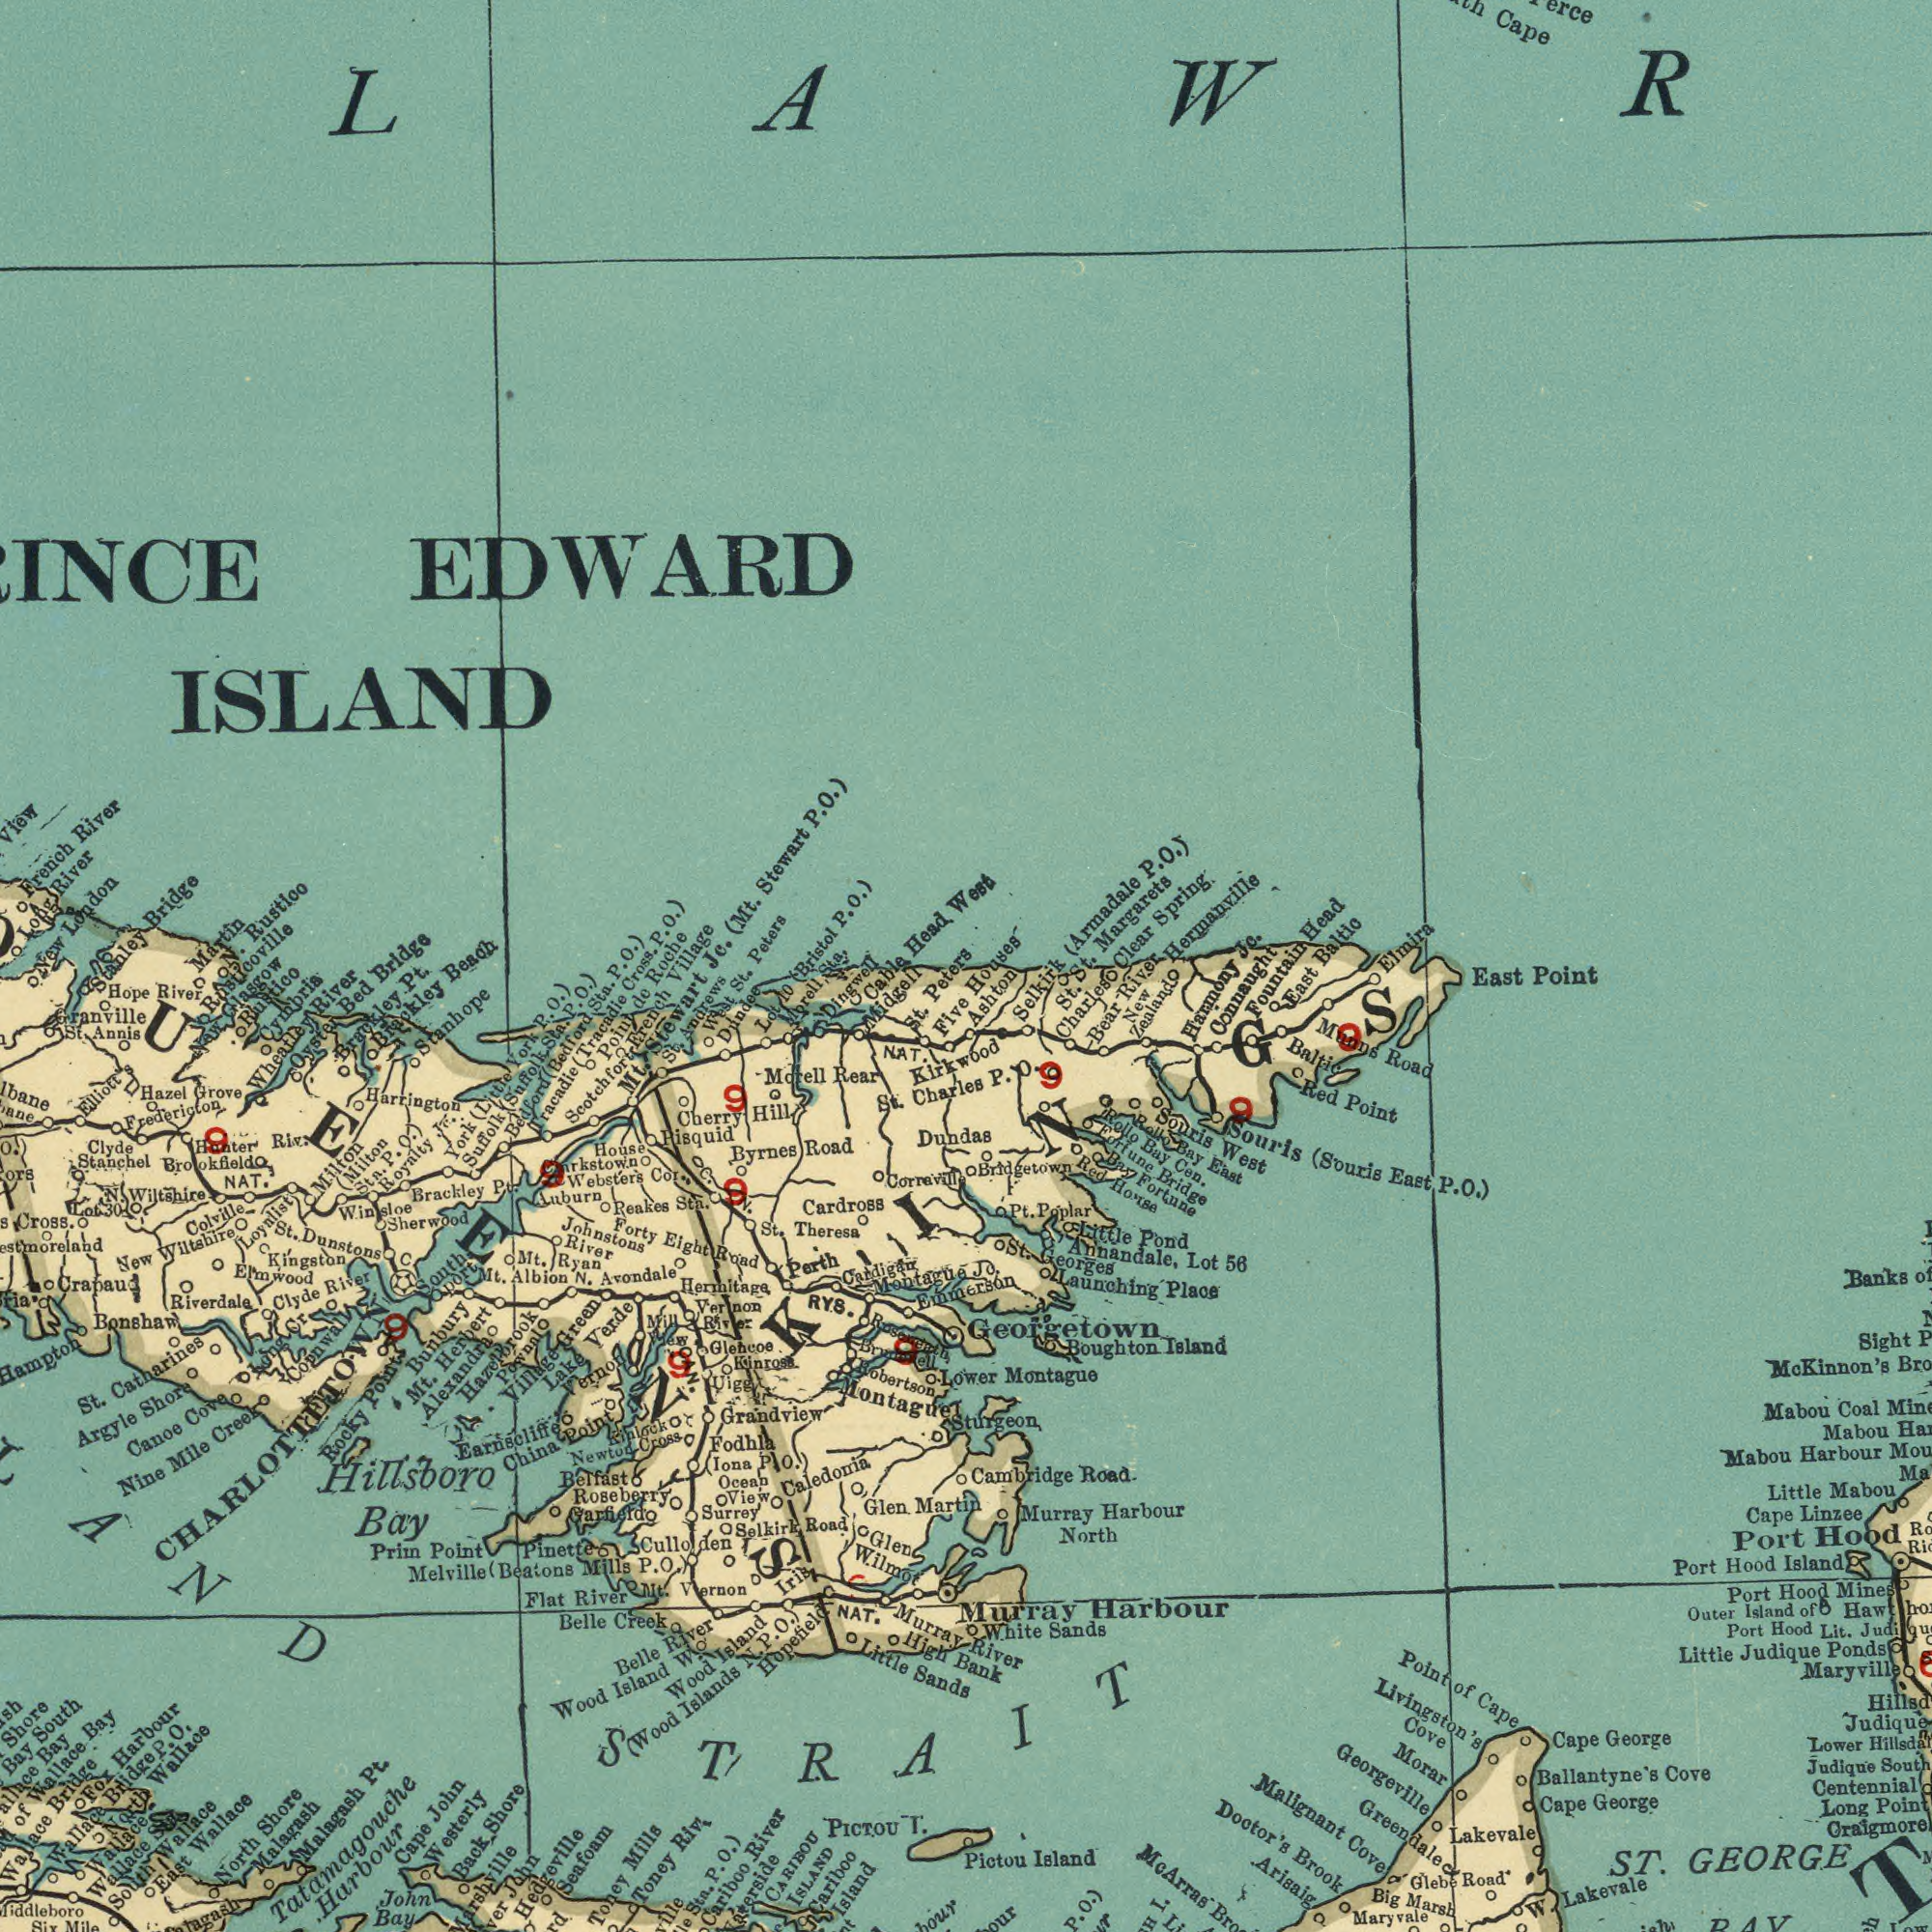What text is visible in the lower-right corner? Malignant Georgeville Harbour GEORGE Brook Livingston's Sands Lakevale Georgetown Cambridge Linzee Cape Judique Montague Lakevale Morar Mc Road Harbour (Souris Port Port Mabou Hood Greendale Cove Ponds Ballantyne's George Road Cape Red Point Point Little Island Port Mabou Boughton Cape Hood George Souris Island East Coal Little Banks Baltic Mabou Mabou Judique Marsh Lit. Port Arisaig Lower Murray Big East Long Sight Road Judique Murray Hood Mc Outer River Place Maryville Point East Maryvale Hood Pictou Cove P. Souris Harbour Point Island ST. KINGS Cape w. BAY Low Glebe of Cove Doctor's Arras Li I. P. 0.) of Kinnon's Bro Mines Island of South Centennial Bank White North Lower Sturgeon Launching St. Georges Annandale, Lot Little Pond Pt. Poplar Bridgetown Red House Bay Fortune Fortune Bridge Rollo Bay Cen. Rollo Bay West East O.) Munns Fountain Connaught Harmony New Zealand Bear River St. Charles St. Selkirk Ashton P. O. Jo. 9 9 9 56 What text can you see in the bottom-left section? Catharines Caledonia Little Argyle PICTOU Belle Wilmot Montague Grandview Bonshaw Creek Brackley I. Melville Murray Shore Seafoam Bay Riverdale Bunbury Canoe Mile Loyalist Sands North Crapaud Malagash Toney Nine Toney Wallace Martin Dunstons Hopefield Hampton Belle Rocky Flat Riv. Fodhla Surrey Colville Mills St. Winsloe NAT. Creek Shore El'mwood Selkirk (Beatons River Brookfield Riv. Clyde STRAIT CHARLOTTETOWN Cariboo Island CARIBOU ISLAND Cariboo River Stn. P. 0.) Hedgeville John Marshville Back Shore John Bay Cape John Westerly Tatamagouche Harbour Malagash Pt. East South Wallace Wallace Wallace Stn Wallace North Six Mile Wallace Bridge P. O. Fox Harbour Wallace Bridge of Wallace Bay Bay Bay South Shore Hillsboro High Glen Glen Corraville Five St. Peters Midgell Cable Dingwell Morell Lot Dundee West St. St. Andrews Mt. Stewart Scotchfort French Poiut de Tracadie (Tracadie Cross. Bedford (Bedford Sta. P. Suffolk (Suffolk Sta. P. O.) York (Little York P. O.) Harrington Stanhope Brackley Brackley Pt. Oyster Bed Wheatley River Cymbria Rustico New Glasgow Hope River Granville Sta. Annis Hazel Grove Elliott's Fredericton Clyde Stanchel O.) Cross. New Wiltshire N. Wiltshire Lot30 Hunter Sta. Kingston River Cove Long Cr. Cornwall Milton (Milton Stn. P. O.) Royalty JE Pt. Sherwood C South Port Point Prim Point Mills P. O.) River Nt. Vernon pinette Road (Iona P. O.) Ocean View Culloden Garfield Roseberry Belfast Newton Cross Mt. Herbert Alexandra Hazelbrook Village Green Lake Verde Earnscliffe Vernon China Point Byrnes Road St. Theresa Cardross Cherry Hill Pisquid Morell Rear Dundas St. Charles House ###rkstown Websters Cor. Auburn Peakes Sta. Forty Eight Road Johnstons River Mt. Ryan Mt. Albion N. Avondale Hermitaga Perth Vernon River Robertson Emmerson Montague Cardigan NAT. Kirkwood NAT. (Wood Islands N. P. O.) Wood Island Wood Island W. Iris Mill View Glencoe Kinross Uigg OAN. Kinlock Pownal 9 9 9 9 9 9 9 RYS. N. C. 30 10 What text is visible in the upper-right corner? Cape Baltic Head Elmira Jc. Hermanville Clear Spring Margarets (Armadale P. O.) Houses West What text is visible in the upper-left corner? French River View ISLAND EDWARD Head Sta. (Bristol P. O.) Peters Jc. (Mt. Stewart P. O.) Village Roche P. O.) O.) Beach Bridge Rusticoville N. Rustico Martin Stanley Bridge New London Long River 